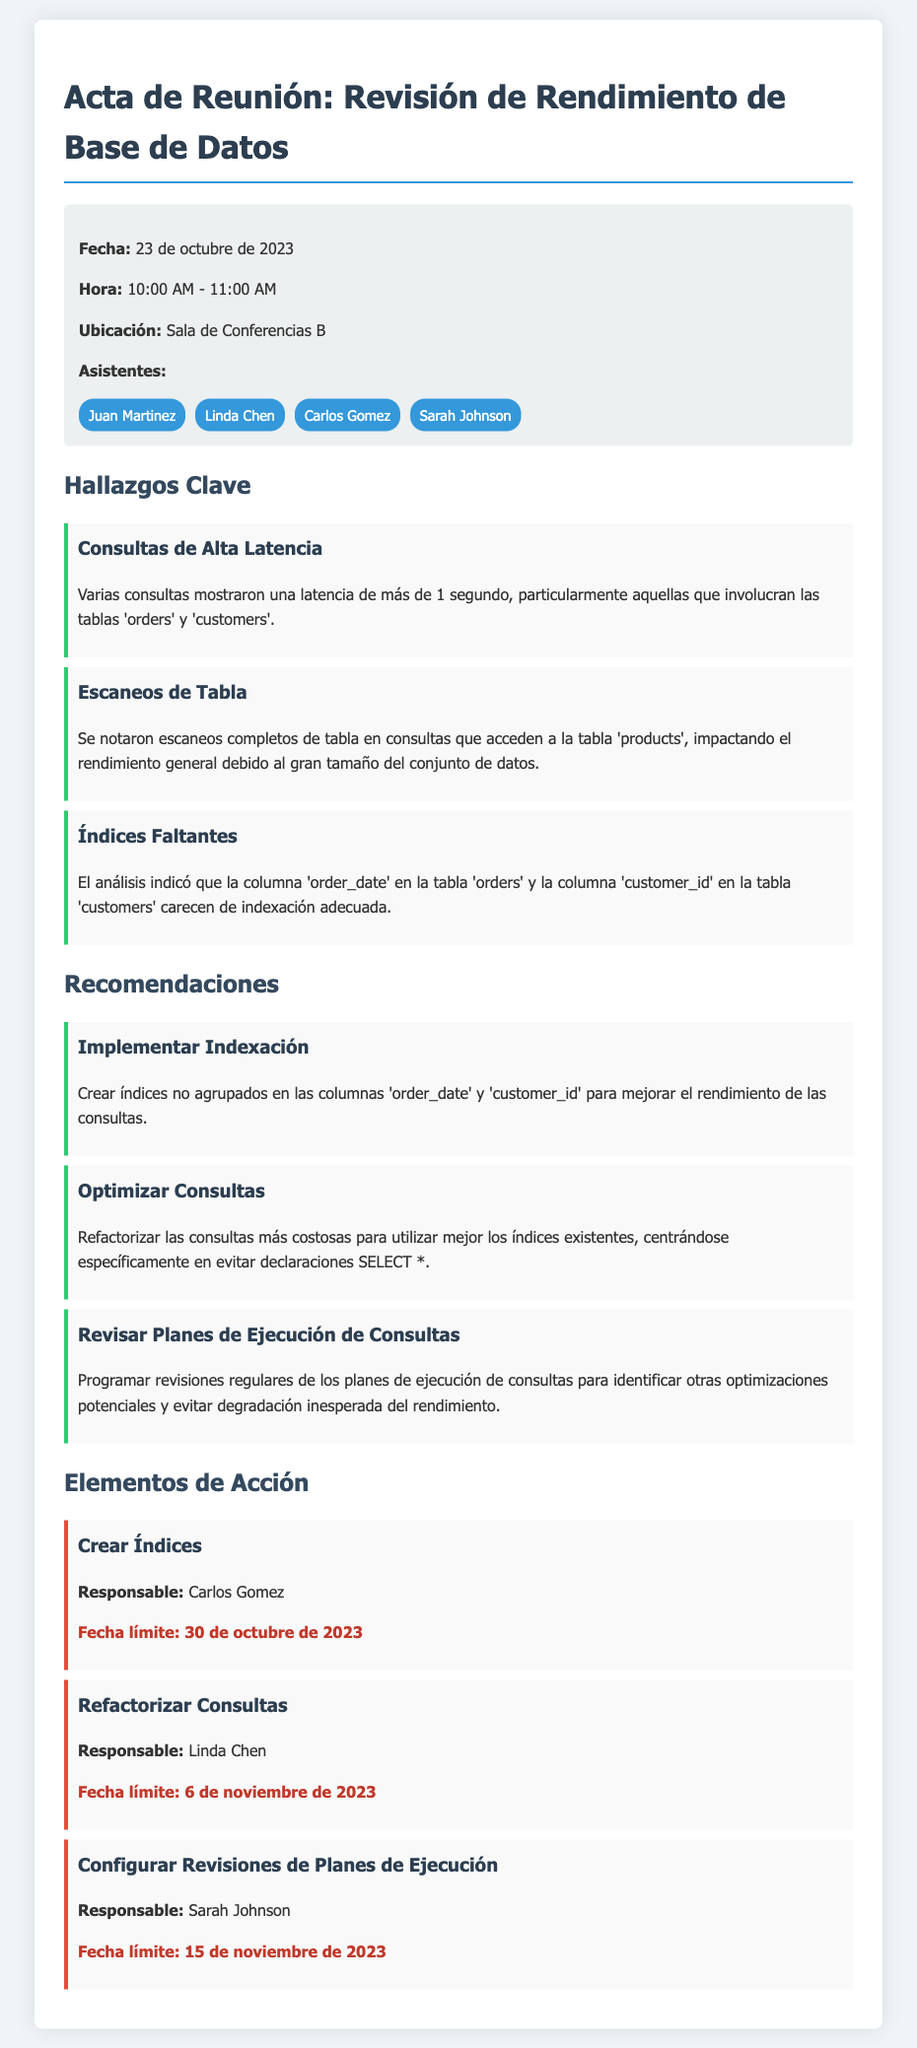¿Cuál fue la fecha de la reunión? La fecha de la reunión se menciona en la parte superior del documento.
Answer: 23 de octubre de 2023 ¿Quién es responsable de crear índices? El documento menciona el responsable de cada acción en los elementos de acción.
Answer: Carlos Gomez ¿Cuáles tablas mostraron consultas de alta latencia? Se indica en los hallazgos clave las tablas implicadas en las consultas con alta latencia.
Answer: orders y customers ¿Qué se recomendó para las consultas más costosas? La recomendación específica se detalla en la sección de recomendaciones referentes a la optimización de consultas.
Answer: Refactorizar las consultas ¿Cuál es la fecha límite para refactorizar las consultas? La fecha límite corresponde a la acción específica que se describe en los elementos de acción.
Answer: 6 de noviembre de 2023 ¿Qué tipo de índices se recomendaron crear? La sección de recomendaciones especifica el tipo de índices a crear para mejorar el rendimiento.
Answer: Índices no agrupados ¿Cuántas personas asistieron a la reunión? La sección de asistentes lista a todos los participantes en la reunión.
Answer: 4 ¿Se notaron escaneos de qué tabla? En los hallazgos claves, se menciona la tabla que presentó escaneos completos.
Answer: products 